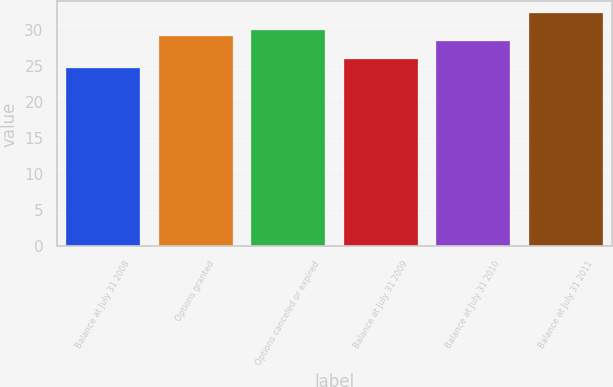Convert chart to OTSL. <chart><loc_0><loc_0><loc_500><loc_500><bar_chart><fcel>Balance at July 31 2008<fcel>Options granted<fcel>Options canceled or expired<fcel>Balance at July 31 2009<fcel>Balance at July 31 2010<fcel>Balance at July 31 2011<nl><fcel>24.7<fcel>29.22<fcel>29.99<fcel>26<fcel>28.45<fcel>32.38<nl></chart> 